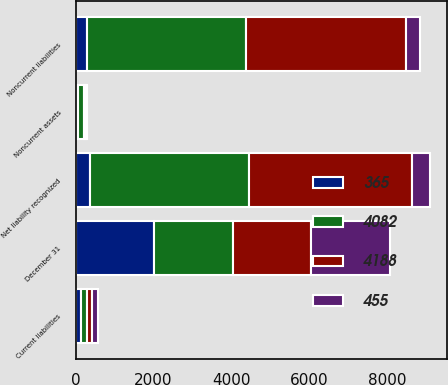Convert chart. <chart><loc_0><loc_0><loc_500><loc_500><stacked_bar_chart><ecel><fcel>December 31<fcel>Noncurrent assets<fcel>Current liabilities<fcel>Noncurrent liabilities<fcel>Net liability recognized<nl><fcel>4188<fcel>2018<fcel>67<fcel>131<fcel>4124<fcel>4188<nl><fcel>4082<fcel>2017<fcel>133<fcel>145<fcel>4070<fcel>4082<nl><fcel>365<fcel>2018<fcel>74<fcel>141<fcel>298<fcel>365<nl><fcel>455<fcel>2017<fcel>33<fcel>150<fcel>338<fcel>455<nl></chart> 